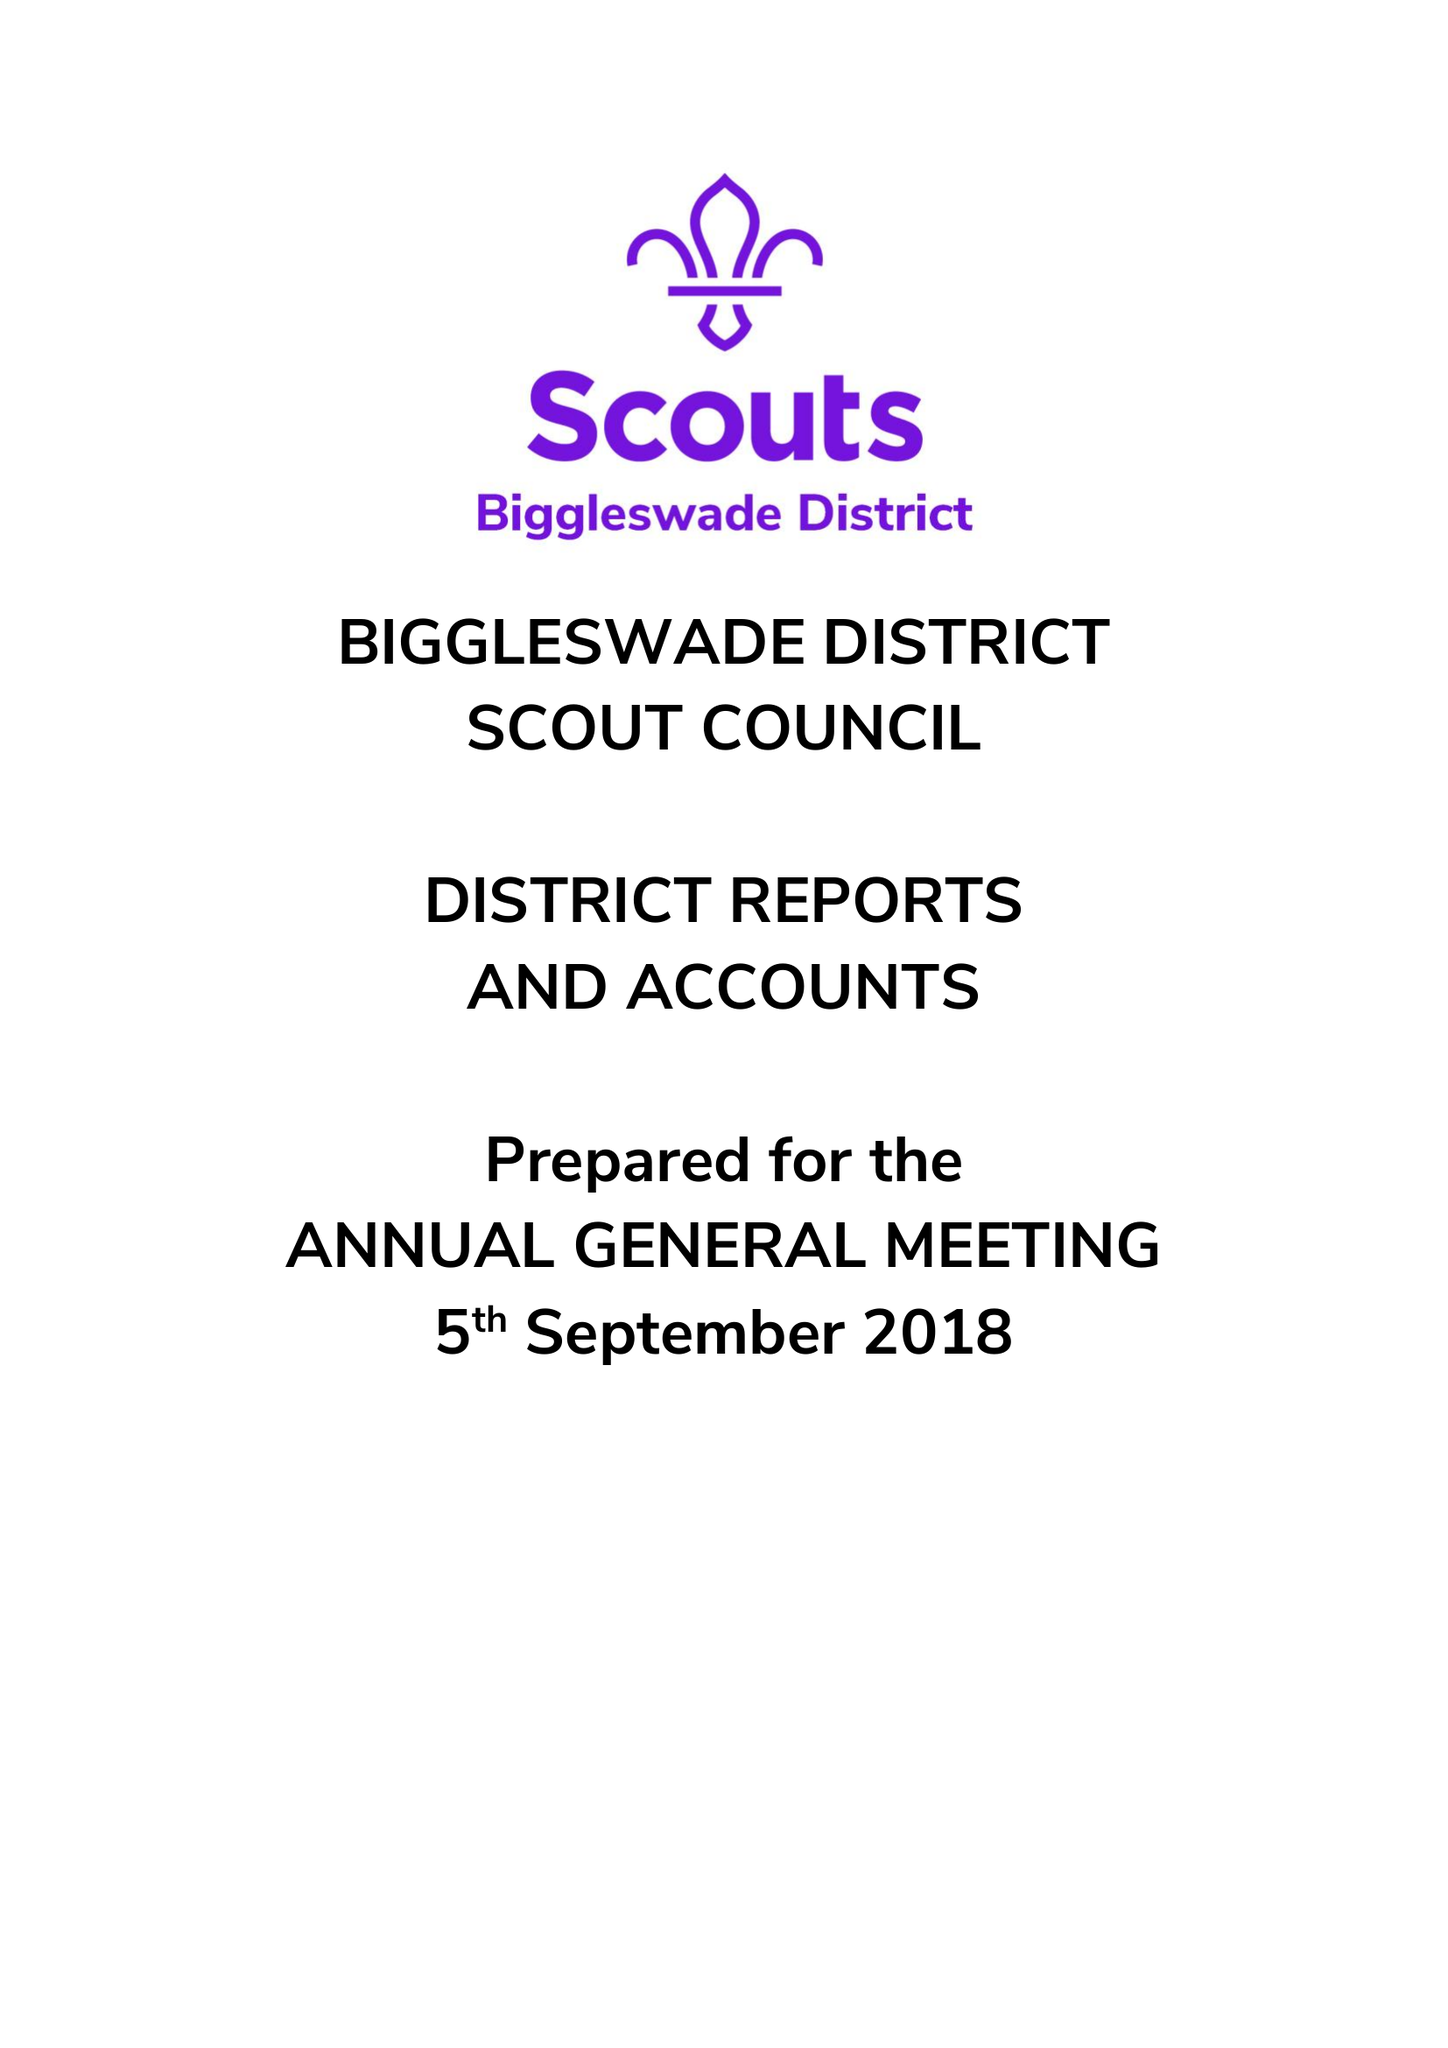What is the value for the income_annually_in_british_pounds?
Answer the question using a single word or phrase. 48511.00 